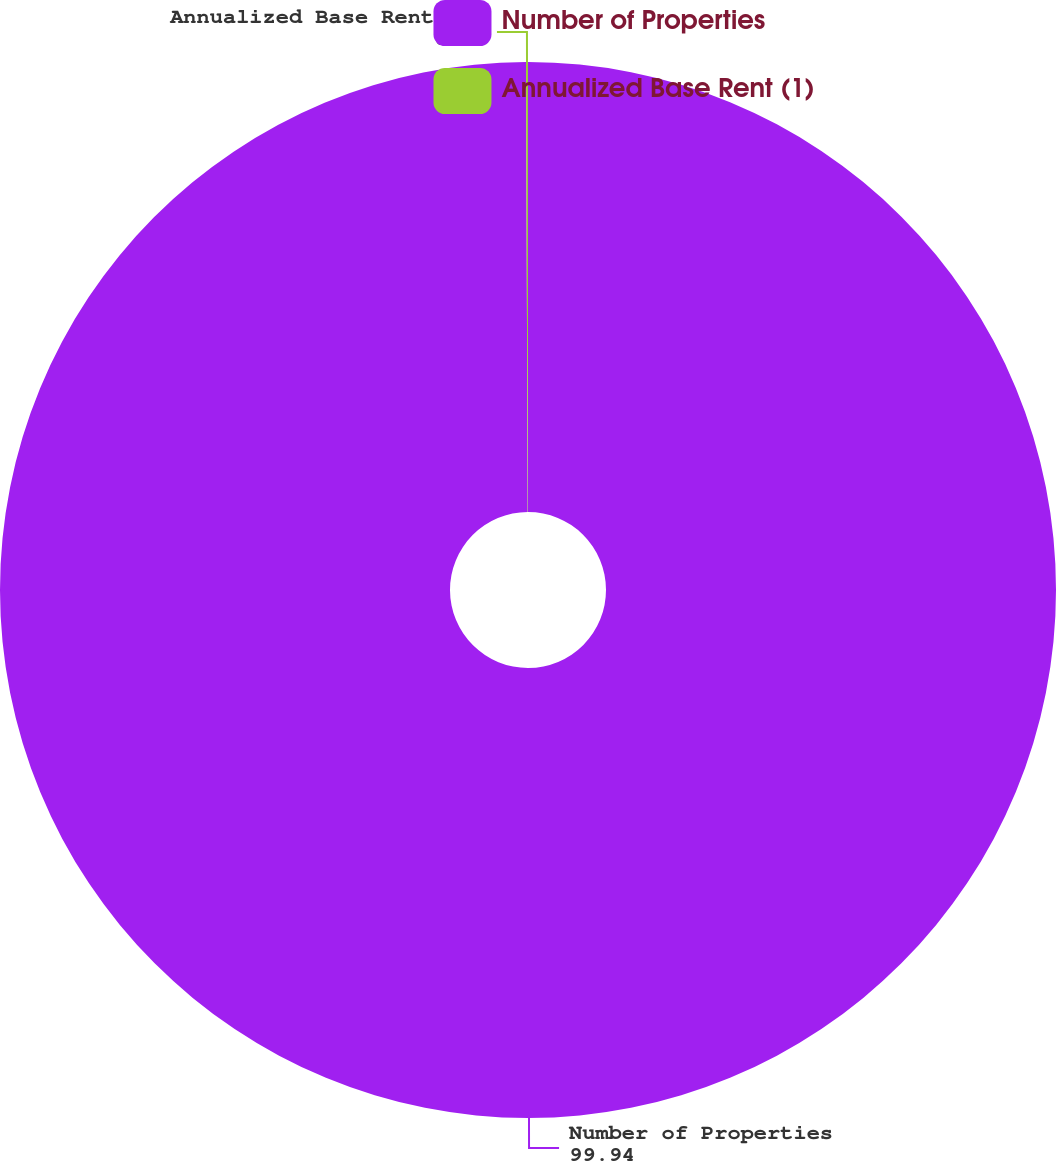<chart> <loc_0><loc_0><loc_500><loc_500><pie_chart><fcel>Number of Properties<fcel>Annualized Base Rent (1)<nl><fcel>99.94%<fcel>0.06%<nl></chart> 